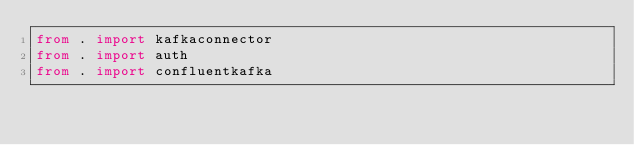<code> <loc_0><loc_0><loc_500><loc_500><_Python_>from . import kafkaconnector
from . import auth
from . import confluentkafka
</code> 